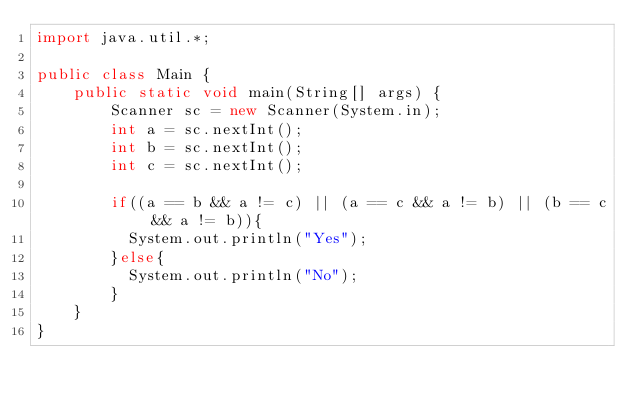Convert code to text. <code><loc_0><loc_0><loc_500><loc_500><_Java_>import java.util.*;

public class Main {
    public static void main(String[] args) {
        Scanner sc = new Scanner(System.in);
        int a = sc.nextInt();
        int b = sc.nextInt();
        int c = sc.nextInt();

        if((a == b && a != c) || (a == c && a != b) || (b == c && a != b)){
          System.out.println("Yes");
        }else{
          System.out.println("No");
        }
    }
}</code> 